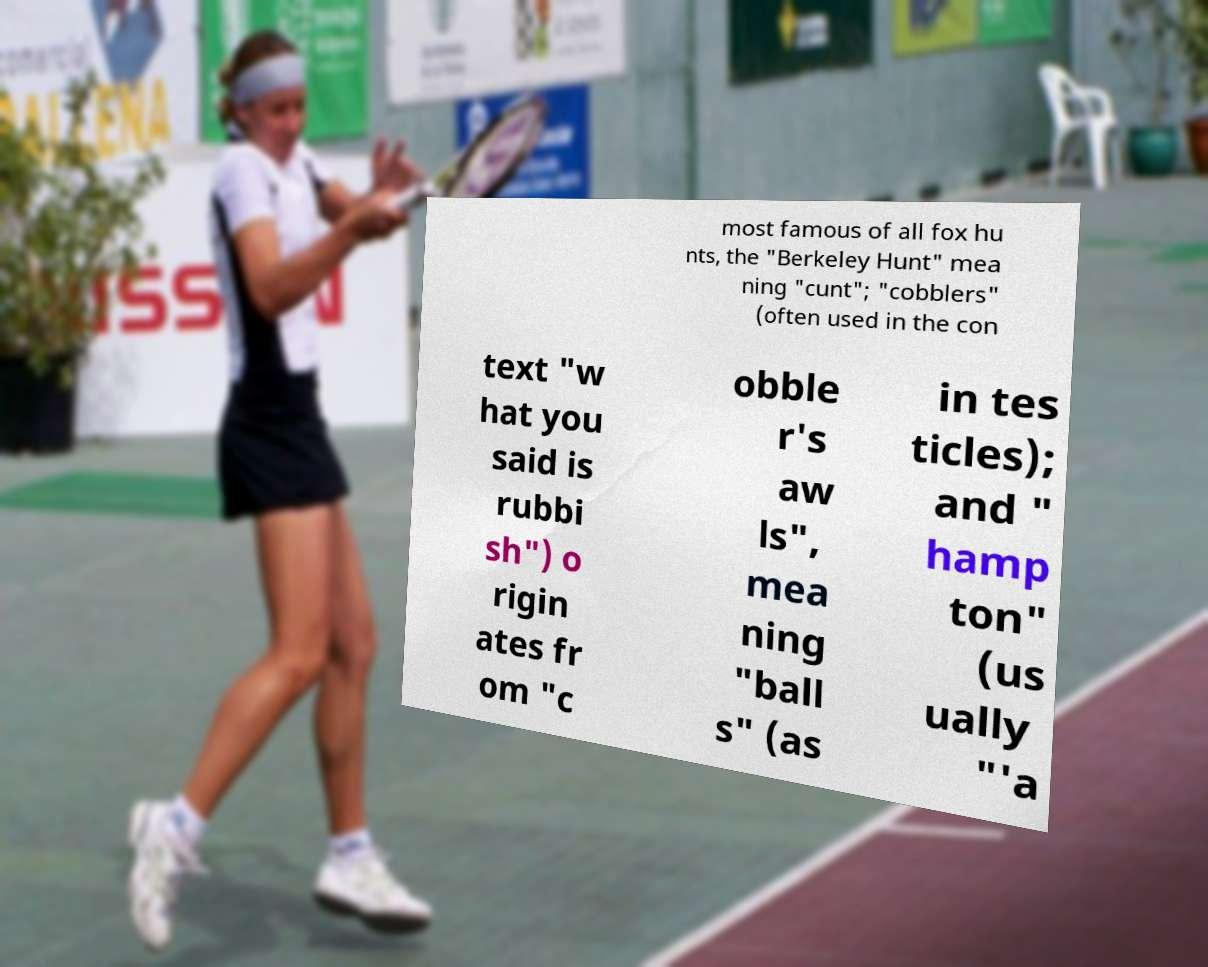Could you extract and type out the text from this image? most famous of all fox hu nts, the "Berkeley Hunt" mea ning "cunt"; "cobblers" (often used in the con text "w hat you said is rubbi sh") o rigin ates fr om "c obble r's aw ls", mea ning "ball s" (as in tes ticles); and " hamp ton" (us ually "'a 